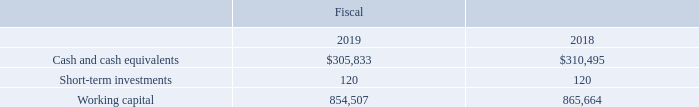Additional sources of cash available to us were international currency lines of credit and bank credit facilities totaling $26.0 million as of September 28, 2019, of which $20.8 million was unused and available. These unsecured international credit facilities were used in Europe and Japan during fiscal 2018. As of September 28, 2019, we had utilized $5.2 million of the international credit facilities as guarantees in Europe.
Our ratio of current assets to current liabilities increased to 4.6:1 at September 28, 2019 compared to 3.3:1 at September 29, 2018. The increase in our ratio was primarily due to lower income taxes payable, partially offset by decreases in our ratio due to lower accounts receivable and inventories. Our cash and cash equivalents, short-term investments and working capital are as follows (in thousands):
Where were the unsecured international credit facilities used in? Europe and japan during fiscal 2018. What led to the increase in the ratio of current assets to current liabilities? Primarily due to lower income taxes payable, partially offset by decreases in our ratio due to lower accounts receivable and inventories. In which years was information on cash and cash equivalents, short-term investments and working capital provided? 2019, 2018. In which year was Cash and cash equivalents larger? 310,495>305,833
Answer: 2018. What was the change in Short-term investments in 2019 from 2018?
Answer scale should be: thousand. 120-120
Answer: 0. What was the percentage change in Short-term investments in 2019 from 2018?
Answer scale should be: percent. (120-120)/120
Answer: 0. 